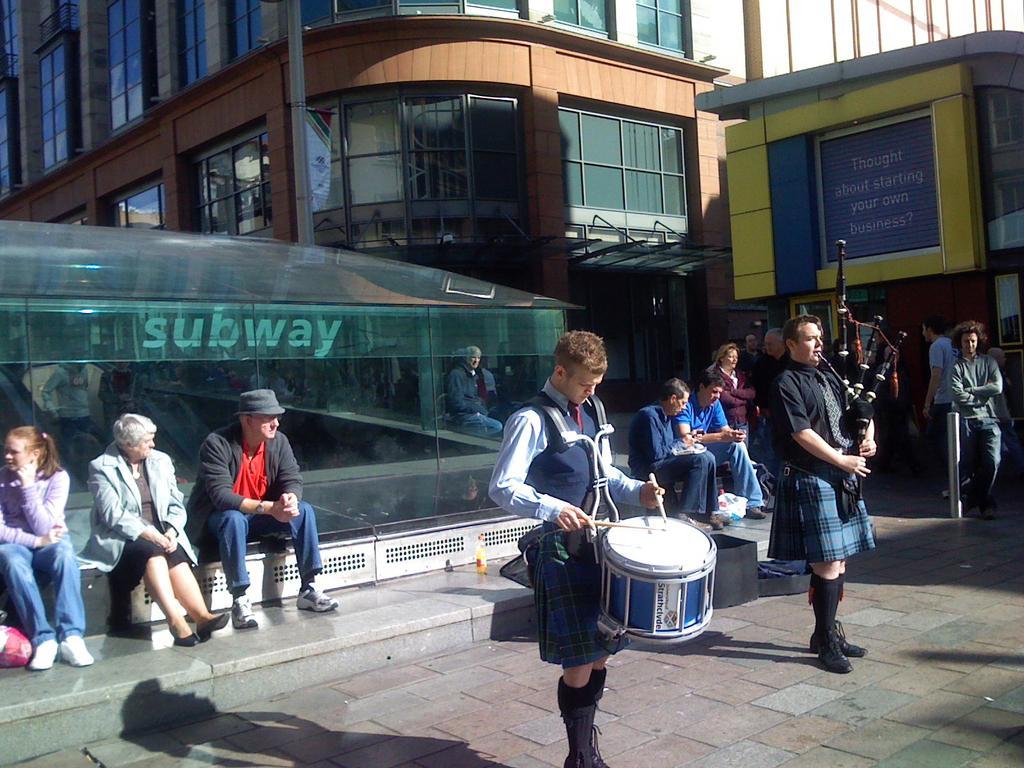How would you summarize this image in a sentence or two? In the foreground of the picture I can see two men standing on the floor and they are playing the musical instruments. I can see a few people sitting on the staircase. There is a man standing on the floor on the right side. In the background, I can see the buildings and glass windows. I can see the subway construction on the left side. 